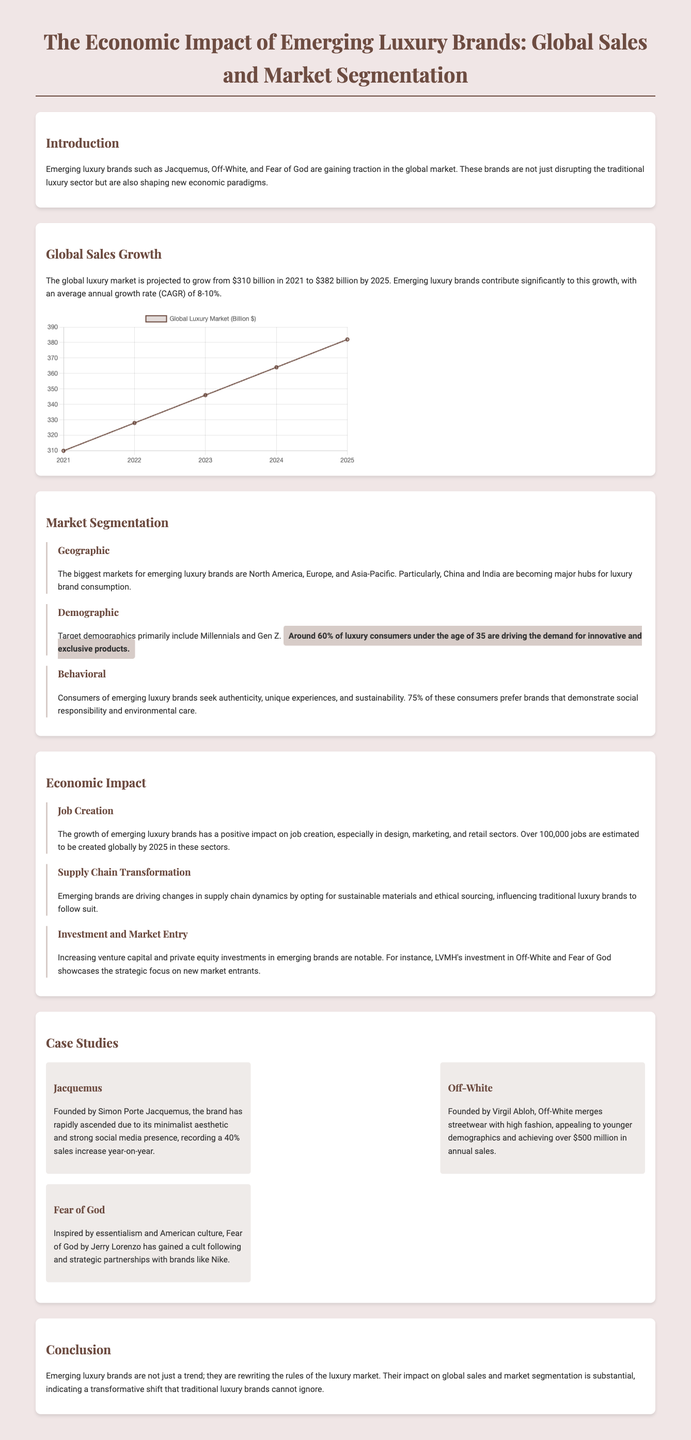what is the projected global luxury market size in 2025? The projected global luxury market size is mentioned in the document, noted to be growing to $382 billion by 2025.
Answer: $382 billion what is the average annual growth rate (CAGR) for emerging luxury brands? The document states that emerging luxury brands have an average annual growth rate (CAGR) of 8-10%.
Answer: 8-10% which regions are identified as the biggest markets for emerging luxury brands? The document mentions North America, Europe, and Asia-Pacific as the biggest markets for emerging luxury brands.
Answer: North America, Europe, Asia-Pacific what percentage of luxury consumers under the age of 35 are driving demand for innovative products? It is specifically highlighted in the document that around 60% of luxury consumers under the age of 35 are driving this demand.
Answer: 60% how many jobs are estimated to be created globally by 2025 due to the growth of emerging luxury brands? The estimate for job creation due to this growth is provided in the document, which states over 100,000 jobs are to be created globally by 2025.
Answer: 100,000 which brand achieved over $500 million in annual sales? The document specifically states that Off-White achieved over $500 million in annual sales.
Answer: Off-White what is a major change emerging luxury brands are driving in the supply chain? The document indicates that emerging brands are opting for sustainable materials and ethical sourcing in their supply chains.
Answer: Sustainable materials what demographic primarily targets emerging luxury brands? The document highlights that Millennials and Gen Z are the primary demographics targeted by emerging luxury brands.
Answer: Millennials and Gen Z how much did Jacquemus's sales increase year-on-year? According to the document, Jacquemus recorded a 40% sales increase year-on-year.
Answer: 40% 